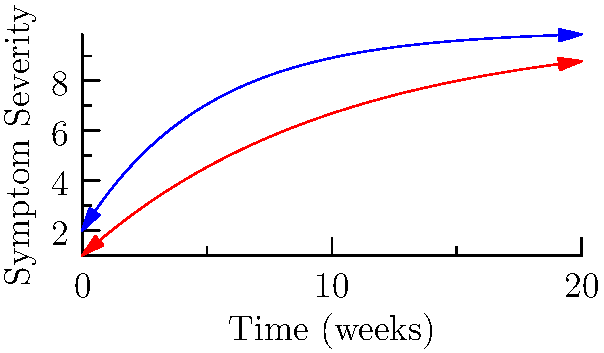Based on the time-series graphs of symptom severity for two patients over 20 weeks, which patient is likely to achieve remission first, and approximately how many weeks will it take? To answer this question, we need to analyze the graphs for both patients:

1. The blue line represents Patient A, and the red line represents Patient B.
2. The dashed line indicates the remission threshold.
3. Remission is achieved when the symptom severity line crosses the remission threshold.

Let's analyze each patient:

Patient A (Blue line):
- Starts with higher symptom severity
- Shows a steeper decline in symptoms
- Crosses the remission threshold at approximately week 12-13

Patient B (Red line):
- Starts with slightly lower symptom severity
- Shows a more gradual decline in symptoms
- Does not cross the remission threshold within the 20-week period shown

The graph for Patient A can be described by the function:
$f_A(x) = 10 - 8e^{-0.2x}$

The graph for Patient B can be described by the function:
$f_B(x) = 10 - 9e^{-0.1x}$

To find the exact crossing point for Patient A, we can solve:
$10 - 8e^{-0.2x} = 10$
$8e^{-0.2x} = 0$
$e^{-0.2x} = 0$

This equation has no exact solution, but graphically we can see it occurs around week 12-13.

Patient B's function will approach but never reach the remission threshold of 10.

Therefore, Patient A is likely to achieve remission first, at approximately 12-13 weeks.
Answer: Patient A, ~12-13 weeks 